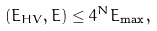Convert formula to latex. <formula><loc_0><loc_0><loc_500><loc_500>( E _ { H V } , E ) \leq 4 ^ { N } E _ { \max } ,</formula> 